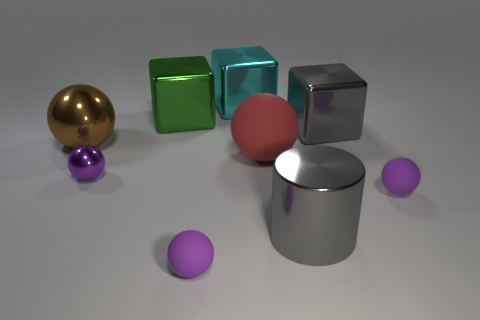How many purple spheres must be subtracted to get 1 purple spheres? 2 Subtract all cyan cylinders. How many purple balls are left? 3 Subtract all brown balls. How many balls are left? 4 Subtract all brown cylinders. Subtract all brown balls. How many cylinders are left? 1 Add 1 tiny purple metal objects. How many objects exist? 10 Subtract all cylinders. How many objects are left? 8 Add 5 purple metallic balls. How many purple metallic balls are left? 6 Add 9 gray matte spheres. How many gray matte spheres exist? 9 Subtract 0 yellow spheres. How many objects are left? 9 Subtract all yellow spheres. Subtract all brown shiny spheres. How many objects are left? 8 